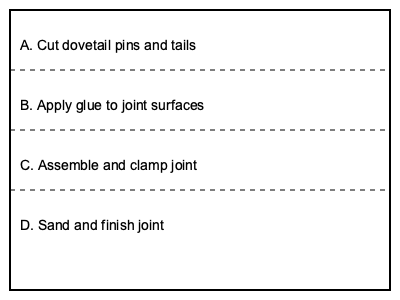What is the correct sequence for assembling a traditional dovetail joint for a Queen Anne side table? The correct sequence for assembling a traditional dovetail joint for a Queen Anne side table is as follows:

1. Cut dovetail pins and tails: This is the first step in creating the joint. The craftsman must carefully measure and cut the pins on one piece of wood and the corresponding tails on the other piece.

2. Apply glue to joint surfaces: Once the pins and tails are cut, a thin layer of wood glue is applied to both surfaces. This ensures a strong bond when the joint is assembled.

3. Assemble and clamp joint: After applying the glue, the two pieces are carefully fitted together, ensuring that the pins and tails interlock properly. Clamps are then applied to hold the joint tightly in place while the glue dries.

4. Sand and finish joint: After the glue has fully dried (usually 24 hours), the excess glue is cleaned off, and the joint is sanded smooth. Finally, the joint is finished to match the rest of the table.

This sequence ensures the strongest and most aesthetically pleasing dovetail joint, which is crucial for the quality and durability expected in a Queen Anne side table.
Answer: A, B, C, D 